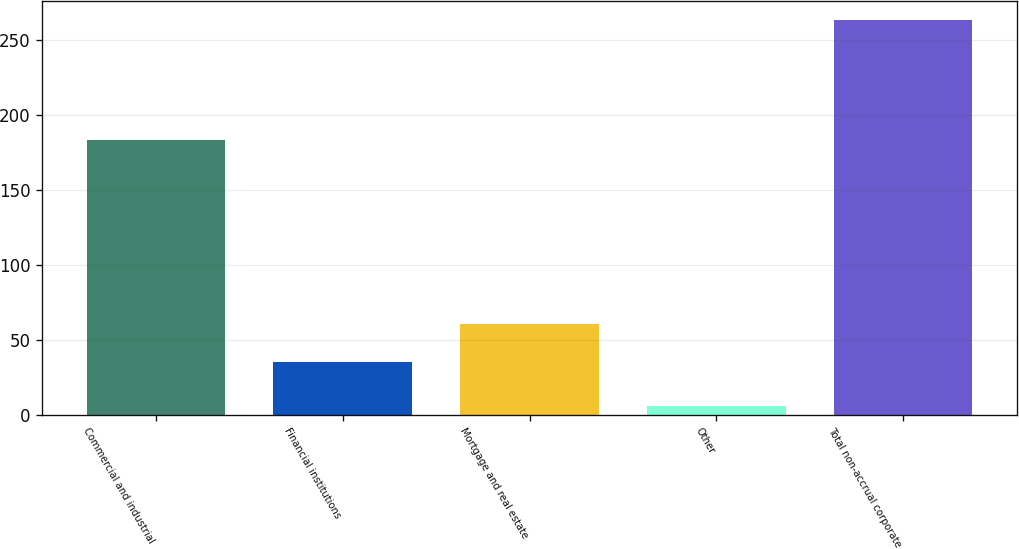<chart> <loc_0><loc_0><loc_500><loc_500><bar_chart><fcel>Commercial and industrial<fcel>Financial institutions<fcel>Mortgage and real estate<fcel>Other<fcel>Total non-accrual corporate<nl><fcel>183<fcel>35<fcel>60.7<fcel>6<fcel>263<nl></chart> 